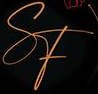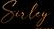What text is displayed in these images sequentially, separated by a semicolon? SF; Suley 